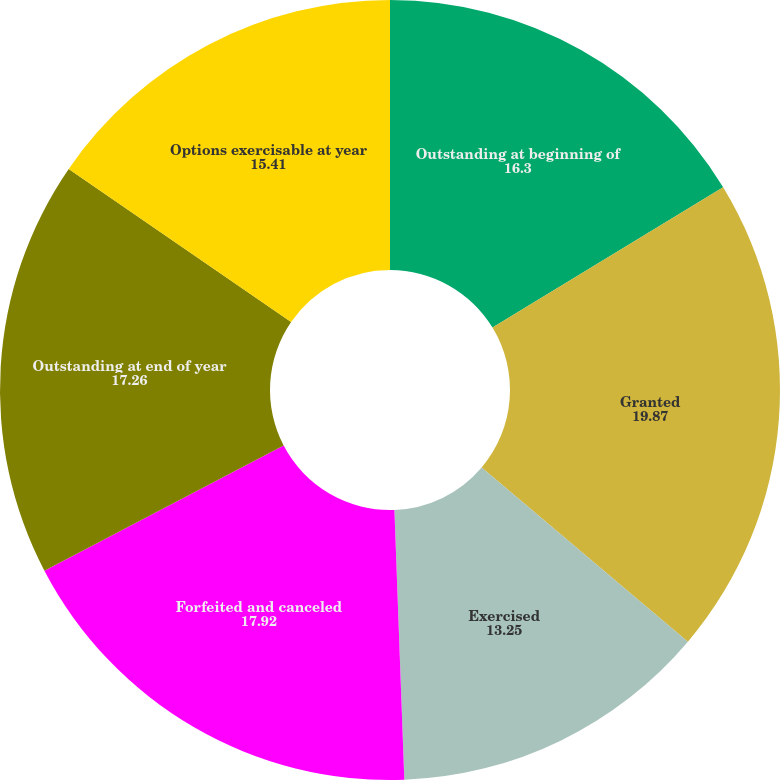Convert chart. <chart><loc_0><loc_0><loc_500><loc_500><pie_chart><fcel>Outstanding at beginning of<fcel>Granted<fcel>Exercised<fcel>Forfeited and canceled<fcel>Outstanding at end of year<fcel>Options exercisable at year<nl><fcel>16.3%<fcel>19.87%<fcel>13.25%<fcel>17.92%<fcel>17.26%<fcel>15.41%<nl></chart> 